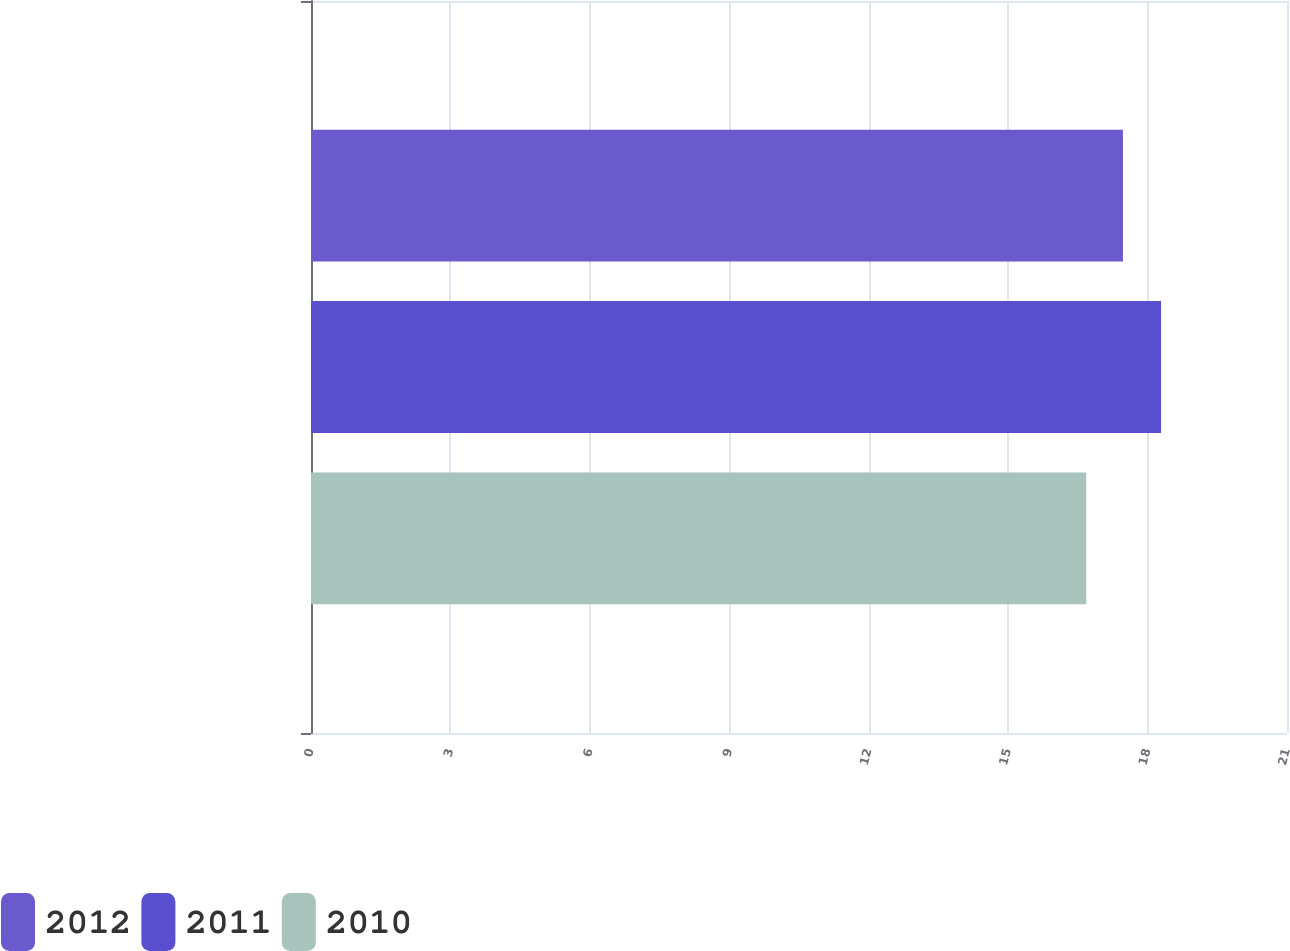Convert chart to OTSL. <chart><loc_0><loc_0><loc_500><loc_500><stacked_bar_chart><ecel><fcel>Unnamed: 1<nl><fcel>2012<fcel>17.47<nl><fcel>2011<fcel>18.29<nl><fcel>2010<fcel>16.68<nl></chart> 